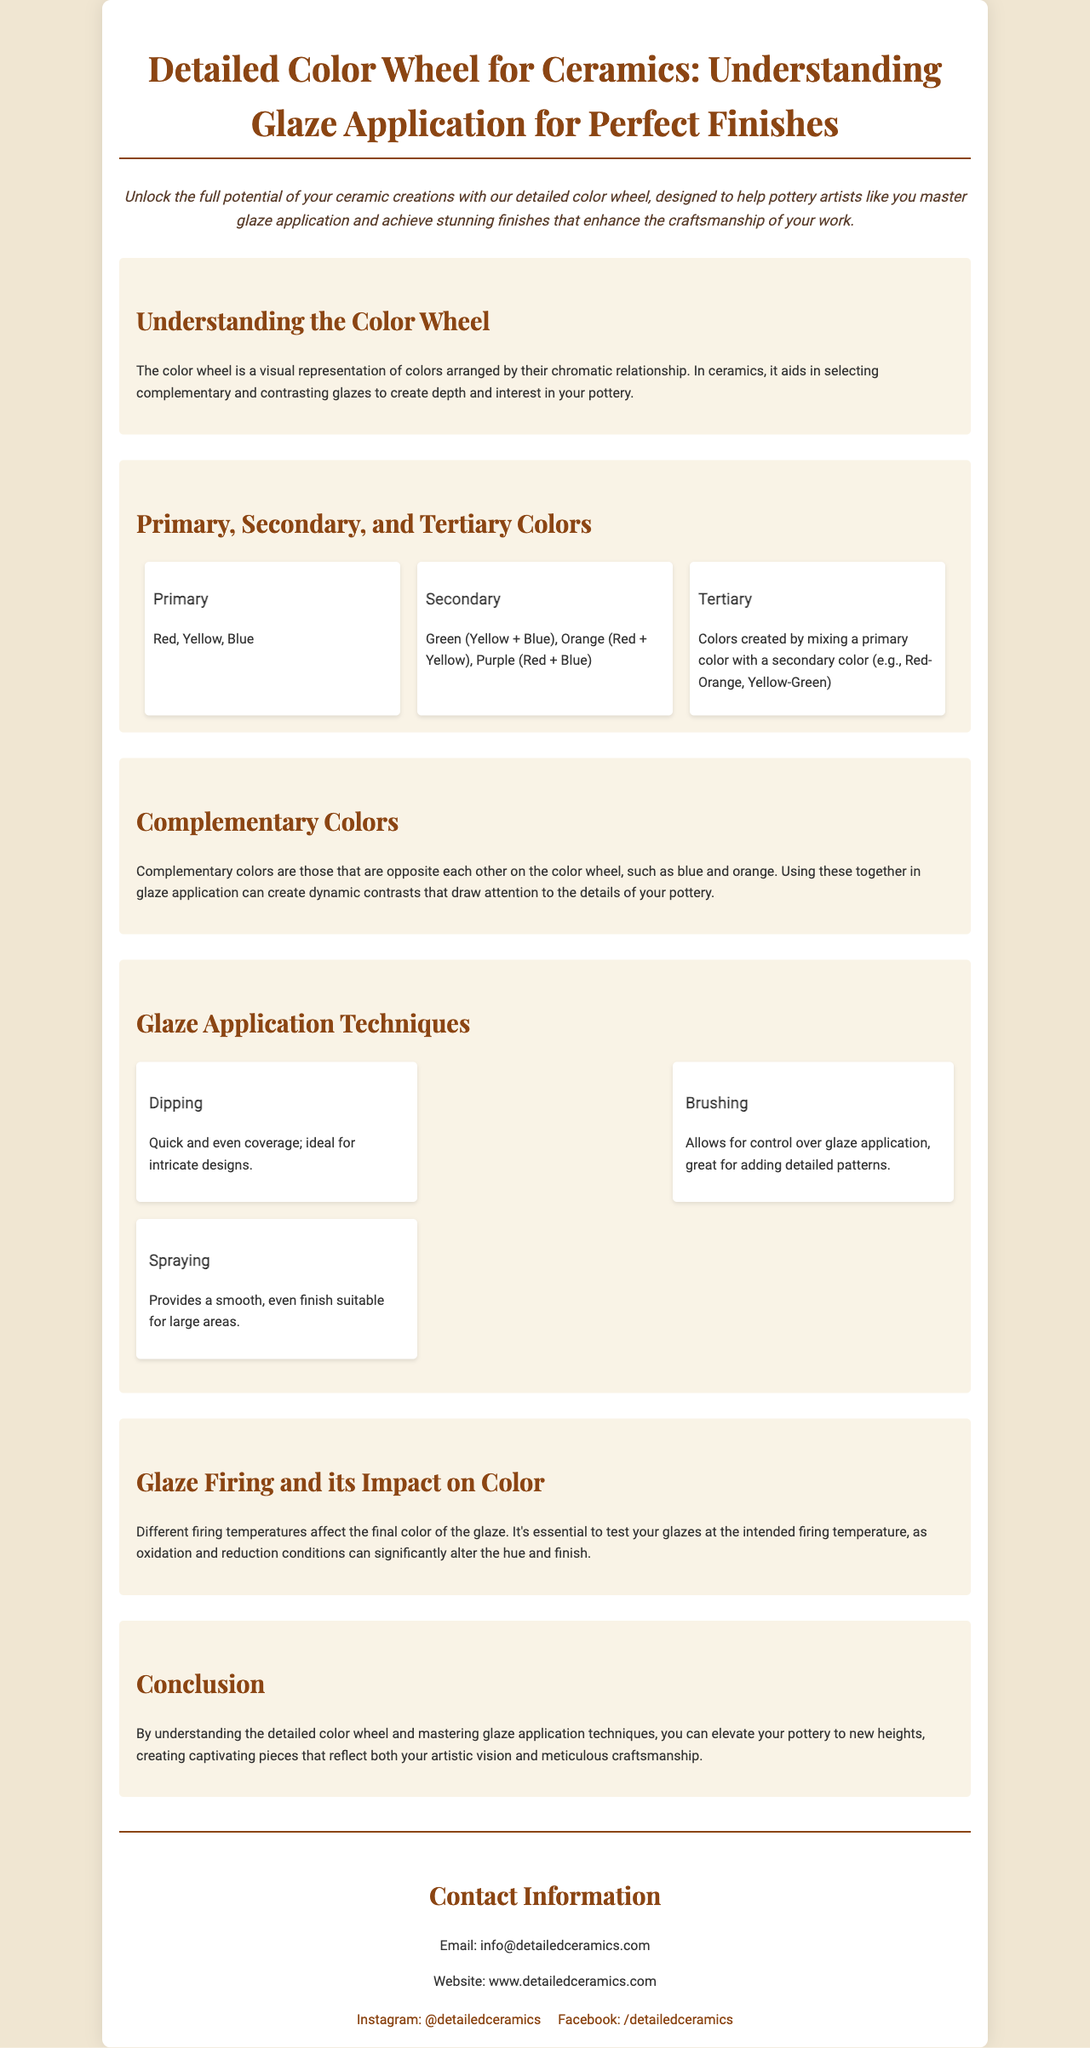What is the title of the brochure? The title is clearly stated at the top of the document, providing an overview of the subject matter.
Answer: Detailed Color Wheel for Ceramics: Understanding Glaze Application for Perfect Finishes What are the primary colors mentioned? The document lists the primary colors in a specific section about color types.
Answer: Red, Yellow, Blue What is the purpose of the color wheel in ceramics? The document explains that the color wheel helps in selecting colors based on their relationships to create visual interest.
Answer: Selecting complementary and contrasting glazes What are the three glaze application techniques listed? The section on techniques describes three distinct methods for applying glaze.
Answer: Dipping, Brushing, Spraying What impact does glaze firing have on color? The document emphasizes the importance of firing conditions affecting the final appearance of the glaze.
Answer: Alters the hue and finish What is the email address provided for contact? The contact information section gives a specific email for inquiries related to the brochure.
Answer: info@detailedceramics.com How many colors comprise the secondary colors? The document specifically states the secondary colors and the way they are derived, which will give a clear count.
Answer: Three What does the intro emphasize for pottery artists? The introductory statement highlights a key benefit of using the color wheel for artists.
Answer: Master glaze application and achieve stunning finishes What type of content structure does this document primarily use? The layout is indicative of a brochure, structured for easy reading with headings for different sections.
Answer: Brochure 